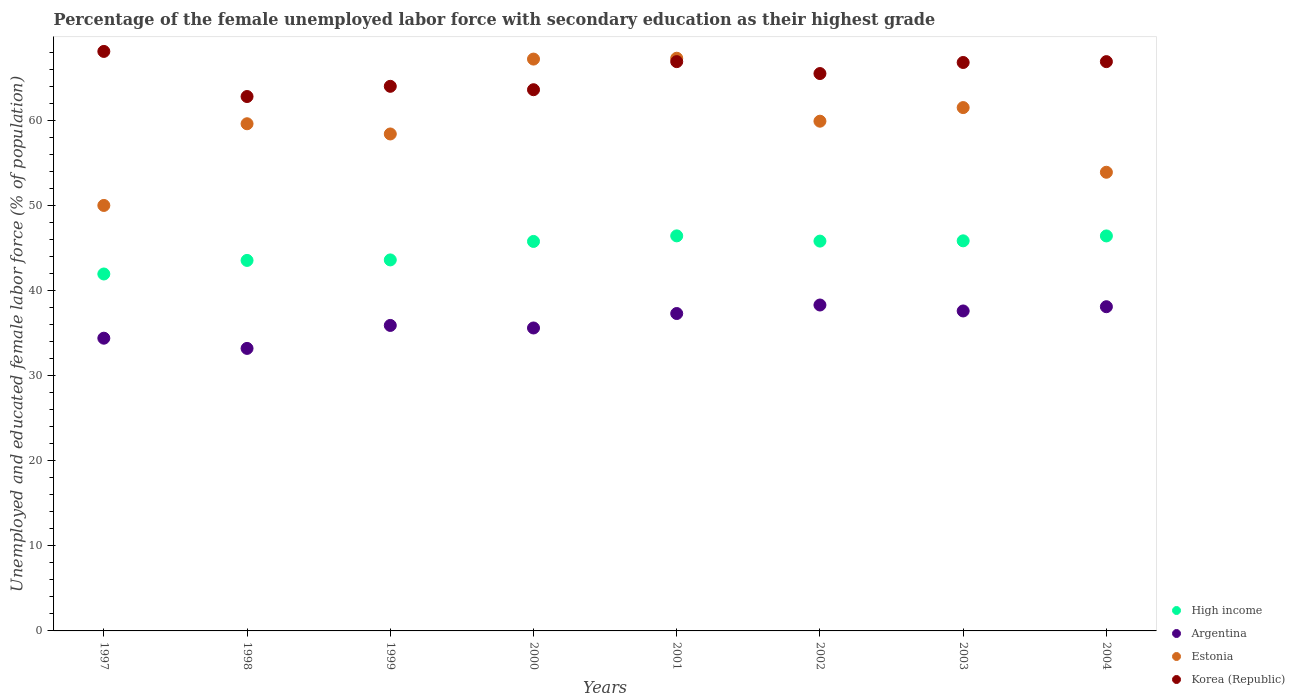How many different coloured dotlines are there?
Ensure brevity in your answer.  4. What is the percentage of the unemployed female labor force with secondary education in Korea (Republic) in 2004?
Make the answer very short. 66.9. Across all years, what is the maximum percentage of the unemployed female labor force with secondary education in Estonia?
Your response must be concise. 67.3. Across all years, what is the minimum percentage of the unemployed female labor force with secondary education in Korea (Republic)?
Your response must be concise. 62.8. In which year was the percentage of the unemployed female labor force with secondary education in High income minimum?
Provide a short and direct response. 1997. What is the total percentage of the unemployed female labor force with secondary education in High income in the graph?
Make the answer very short. 359.35. What is the difference between the percentage of the unemployed female labor force with secondary education in Korea (Republic) in 1997 and that in 1998?
Ensure brevity in your answer.  5.3. What is the difference between the percentage of the unemployed female labor force with secondary education in Argentina in 1997 and the percentage of the unemployed female labor force with secondary education in High income in 1999?
Give a very brief answer. -9.2. What is the average percentage of the unemployed female labor force with secondary education in Estonia per year?
Your response must be concise. 59.73. In the year 1999, what is the difference between the percentage of the unemployed female labor force with secondary education in Estonia and percentage of the unemployed female labor force with secondary education in Korea (Republic)?
Provide a succinct answer. -5.6. In how many years, is the percentage of the unemployed female labor force with secondary education in Argentina greater than 62 %?
Give a very brief answer. 0. What is the ratio of the percentage of the unemployed female labor force with secondary education in Argentina in 1999 to that in 2003?
Offer a terse response. 0.95. Is the percentage of the unemployed female labor force with secondary education in Argentina in 1997 less than that in 2002?
Your response must be concise. Yes. What is the difference between the highest and the second highest percentage of the unemployed female labor force with secondary education in Argentina?
Keep it short and to the point. 0.2. What is the difference between the highest and the lowest percentage of the unemployed female labor force with secondary education in High income?
Your answer should be very brief. 4.48. Is the sum of the percentage of the unemployed female labor force with secondary education in Argentina in 2000 and 2003 greater than the maximum percentage of the unemployed female labor force with secondary education in Korea (Republic) across all years?
Offer a terse response. Yes. Does the percentage of the unemployed female labor force with secondary education in Estonia monotonically increase over the years?
Provide a short and direct response. No. What is the difference between two consecutive major ticks on the Y-axis?
Provide a succinct answer. 10. Are the values on the major ticks of Y-axis written in scientific E-notation?
Your response must be concise. No. How many legend labels are there?
Make the answer very short. 4. How are the legend labels stacked?
Your response must be concise. Vertical. What is the title of the graph?
Provide a short and direct response. Percentage of the female unemployed labor force with secondary education as their highest grade. What is the label or title of the X-axis?
Provide a succinct answer. Years. What is the label or title of the Y-axis?
Ensure brevity in your answer.  Unemployed and educated female labor force (% of population). What is the Unemployed and educated female labor force (% of population) in High income in 1997?
Your response must be concise. 41.95. What is the Unemployed and educated female labor force (% of population) in Argentina in 1997?
Your answer should be compact. 34.4. What is the Unemployed and educated female labor force (% of population) of Korea (Republic) in 1997?
Provide a succinct answer. 68.1. What is the Unemployed and educated female labor force (% of population) in High income in 1998?
Your response must be concise. 43.54. What is the Unemployed and educated female labor force (% of population) of Argentina in 1998?
Provide a succinct answer. 33.2. What is the Unemployed and educated female labor force (% of population) in Estonia in 1998?
Provide a succinct answer. 59.6. What is the Unemployed and educated female labor force (% of population) in Korea (Republic) in 1998?
Ensure brevity in your answer.  62.8. What is the Unemployed and educated female labor force (% of population) in High income in 1999?
Keep it short and to the point. 43.6. What is the Unemployed and educated female labor force (% of population) of Argentina in 1999?
Make the answer very short. 35.9. What is the Unemployed and educated female labor force (% of population) of Estonia in 1999?
Provide a short and direct response. 58.4. What is the Unemployed and educated female labor force (% of population) in Korea (Republic) in 1999?
Offer a terse response. 64. What is the Unemployed and educated female labor force (% of population) in High income in 2000?
Ensure brevity in your answer.  45.77. What is the Unemployed and educated female labor force (% of population) in Argentina in 2000?
Offer a terse response. 35.6. What is the Unemployed and educated female labor force (% of population) of Estonia in 2000?
Give a very brief answer. 67.2. What is the Unemployed and educated female labor force (% of population) in Korea (Republic) in 2000?
Keep it short and to the point. 63.6. What is the Unemployed and educated female labor force (% of population) in High income in 2001?
Ensure brevity in your answer.  46.42. What is the Unemployed and educated female labor force (% of population) in Argentina in 2001?
Give a very brief answer. 37.3. What is the Unemployed and educated female labor force (% of population) of Estonia in 2001?
Give a very brief answer. 67.3. What is the Unemployed and educated female labor force (% of population) in Korea (Republic) in 2001?
Keep it short and to the point. 66.9. What is the Unemployed and educated female labor force (% of population) in High income in 2002?
Your answer should be very brief. 45.81. What is the Unemployed and educated female labor force (% of population) of Argentina in 2002?
Your response must be concise. 38.3. What is the Unemployed and educated female labor force (% of population) in Estonia in 2002?
Ensure brevity in your answer.  59.9. What is the Unemployed and educated female labor force (% of population) of Korea (Republic) in 2002?
Keep it short and to the point. 65.5. What is the Unemployed and educated female labor force (% of population) of High income in 2003?
Your answer should be very brief. 45.84. What is the Unemployed and educated female labor force (% of population) of Argentina in 2003?
Your answer should be compact. 37.6. What is the Unemployed and educated female labor force (% of population) of Estonia in 2003?
Keep it short and to the point. 61.5. What is the Unemployed and educated female labor force (% of population) in Korea (Republic) in 2003?
Ensure brevity in your answer.  66.8. What is the Unemployed and educated female labor force (% of population) in High income in 2004?
Provide a succinct answer. 46.42. What is the Unemployed and educated female labor force (% of population) in Argentina in 2004?
Offer a very short reply. 38.1. What is the Unemployed and educated female labor force (% of population) of Estonia in 2004?
Ensure brevity in your answer.  53.9. What is the Unemployed and educated female labor force (% of population) of Korea (Republic) in 2004?
Your answer should be very brief. 66.9. Across all years, what is the maximum Unemployed and educated female labor force (% of population) in High income?
Give a very brief answer. 46.42. Across all years, what is the maximum Unemployed and educated female labor force (% of population) of Argentina?
Provide a succinct answer. 38.3. Across all years, what is the maximum Unemployed and educated female labor force (% of population) in Estonia?
Your answer should be very brief. 67.3. Across all years, what is the maximum Unemployed and educated female labor force (% of population) of Korea (Republic)?
Make the answer very short. 68.1. Across all years, what is the minimum Unemployed and educated female labor force (% of population) in High income?
Ensure brevity in your answer.  41.95. Across all years, what is the minimum Unemployed and educated female labor force (% of population) of Argentina?
Keep it short and to the point. 33.2. Across all years, what is the minimum Unemployed and educated female labor force (% of population) in Korea (Republic)?
Your answer should be compact. 62.8. What is the total Unemployed and educated female labor force (% of population) in High income in the graph?
Ensure brevity in your answer.  359.35. What is the total Unemployed and educated female labor force (% of population) in Argentina in the graph?
Give a very brief answer. 290.4. What is the total Unemployed and educated female labor force (% of population) of Estonia in the graph?
Your response must be concise. 477.8. What is the total Unemployed and educated female labor force (% of population) of Korea (Republic) in the graph?
Give a very brief answer. 524.6. What is the difference between the Unemployed and educated female labor force (% of population) of High income in 1997 and that in 1998?
Offer a very short reply. -1.59. What is the difference between the Unemployed and educated female labor force (% of population) of Argentina in 1997 and that in 1998?
Ensure brevity in your answer.  1.2. What is the difference between the Unemployed and educated female labor force (% of population) in Estonia in 1997 and that in 1998?
Your answer should be compact. -9.6. What is the difference between the Unemployed and educated female labor force (% of population) of Korea (Republic) in 1997 and that in 1998?
Your response must be concise. 5.3. What is the difference between the Unemployed and educated female labor force (% of population) in High income in 1997 and that in 1999?
Provide a succinct answer. -1.65. What is the difference between the Unemployed and educated female labor force (% of population) of Estonia in 1997 and that in 1999?
Give a very brief answer. -8.4. What is the difference between the Unemployed and educated female labor force (% of population) in High income in 1997 and that in 2000?
Offer a very short reply. -3.83. What is the difference between the Unemployed and educated female labor force (% of population) of Estonia in 1997 and that in 2000?
Give a very brief answer. -17.2. What is the difference between the Unemployed and educated female labor force (% of population) in Korea (Republic) in 1997 and that in 2000?
Give a very brief answer. 4.5. What is the difference between the Unemployed and educated female labor force (% of population) in High income in 1997 and that in 2001?
Offer a very short reply. -4.48. What is the difference between the Unemployed and educated female labor force (% of population) of Estonia in 1997 and that in 2001?
Make the answer very short. -17.3. What is the difference between the Unemployed and educated female labor force (% of population) of High income in 1997 and that in 2002?
Offer a terse response. -3.86. What is the difference between the Unemployed and educated female labor force (% of population) in Argentina in 1997 and that in 2002?
Your answer should be very brief. -3.9. What is the difference between the Unemployed and educated female labor force (% of population) in Estonia in 1997 and that in 2002?
Your answer should be very brief. -9.9. What is the difference between the Unemployed and educated female labor force (% of population) in Korea (Republic) in 1997 and that in 2002?
Provide a succinct answer. 2.6. What is the difference between the Unemployed and educated female labor force (% of population) in High income in 1997 and that in 2003?
Provide a succinct answer. -3.9. What is the difference between the Unemployed and educated female labor force (% of population) of Argentina in 1997 and that in 2003?
Ensure brevity in your answer.  -3.2. What is the difference between the Unemployed and educated female labor force (% of population) in Estonia in 1997 and that in 2003?
Your answer should be very brief. -11.5. What is the difference between the Unemployed and educated female labor force (% of population) of Korea (Republic) in 1997 and that in 2003?
Offer a very short reply. 1.3. What is the difference between the Unemployed and educated female labor force (% of population) of High income in 1997 and that in 2004?
Give a very brief answer. -4.47. What is the difference between the Unemployed and educated female labor force (% of population) of Korea (Republic) in 1997 and that in 2004?
Make the answer very short. 1.2. What is the difference between the Unemployed and educated female labor force (% of population) in High income in 1998 and that in 1999?
Provide a succinct answer. -0.06. What is the difference between the Unemployed and educated female labor force (% of population) of High income in 1998 and that in 2000?
Your answer should be very brief. -2.23. What is the difference between the Unemployed and educated female labor force (% of population) in Argentina in 1998 and that in 2000?
Provide a succinct answer. -2.4. What is the difference between the Unemployed and educated female labor force (% of population) of Estonia in 1998 and that in 2000?
Ensure brevity in your answer.  -7.6. What is the difference between the Unemployed and educated female labor force (% of population) in Korea (Republic) in 1998 and that in 2000?
Your answer should be very brief. -0.8. What is the difference between the Unemployed and educated female labor force (% of population) in High income in 1998 and that in 2001?
Give a very brief answer. -2.88. What is the difference between the Unemployed and educated female labor force (% of population) in Estonia in 1998 and that in 2001?
Make the answer very short. -7.7. What is the difference between the Unemployed and educated female labor force (% of population) of Korea (Republic) in 1998 and that in 2001?
Offer a very short reply. -4.1. What is the difference between the Unemployed and educated female labor force (% of population) of High income in 1998 and that in 2002?
Your answer should be very brief. -2.27. What is the difference between the Unemployed and educated female labor force (% of population) of Estonia in 1998 and that in 2002?
Your answer should be compact. -0.3. What is the difference between the Unemployed and educated female labor force (% of population) of Korea (Republic) in 1998 and that in 2002?
Provide a short and direct response. -2.7. What is the difference between the Unemployed and educated female labor force (% of population) of High income in 1998 and that in 2003?
Make the answer very short. -2.3. What is the difference between the Unemployed and educated female labor force (% of population) in Estonia in 1998 and that in 2003?
Give a very brief answer. -1.9. What is the difference between the Unemployed and educated female labor force (% of population) of High income in 1998 and that in 2004?
Your answer should be compact. -2.88. What is the difference between the Unemployed and educated female labor force (% of population) of Argentina in 1998 and that in 2004?
Ensure brevity in your answer.  -4.9. What is the difference between the Unemployed and educated female labor force (% of population) of Estonia in 1998 and that in 2004?
Ensure brevity in your answer.  5.7. What is the difference between the Unemployed and educated female labor force (% of population) of High income in 1999 and that in 2000?
Make the answer very short. -2.17. What is the difference between the Unemployed and educated female labor force (% of population) in Argentina in 1999 and that in 2000?
Offer a terse response. 0.3. What is the difference between the Unemployed and educated female labor force (% of population) of Korea (Republic) in 1999 and that in 2000?
Provide a short and direct response. 0.4. What is the difference between the Unemployed and educated female labor force (% of population) of High income in 1999 and that in 2001?
Your answer should be very brief. -2.82. What is the difference between the Unemployed and educated female labor force (% of population) in High income in 1999 and that in 2002?
Your answer should be very brief. -2.21. What is the difference between the Unemployed and educated female labor force (% of population) of Korea (Republic) in 1999 and that in 2002?
Your response must be concise. -1.5. What is the difference between the Unemployed and educated female labor force (% of population) in High income in 1999 and that in 2003?
Give a very brief answer. -2.24. What is the difference between the Unemployed and educated female labor force (% of population) in Argentina in 1999 and that in 2003?
Your response must be concise. -1.7. What is the difference between the Unemployed and educated female labor force (% of population) of Estonia in 1999 and that in 2003?
Offer a terse response. -3.1. What is the difference between the Unemployed and educated female labor force (% of population) of High income in 1999 and that in 2004?
Make the answer very short. -2.82. What is the difference between the Unemployed and educated female labor force (% of population) in Argentina in 1999 and that in 2004?
Offer a very short reply. -2.2. What is the difference between the Unemployed and educated female labor force (% of population) of Korea (Republic) in 1999 and that in 2004?
Keep it short and to the point. -2.9. What is the difference between the Unemployed and educated female labor force (% of population) in High income in 2000 and that in 2001?
Make the answer very short. -0.65. What is the difference between the Unemployed and educated female labor force (% of population) in Argentina in 2000 and that in 2001?
Give a very brief answer. -1.7. What is the difference between the Unemployed and educated female labor force (% of population) of Korea (Republic) in 2000 and that in 2001?
Make the answer very short. -3.3. What is the difference between the Unemployed and educated female labor force (% of population) in High income in 2000 and that in 2002?
Offer a very short reply. -0.04. What is the difference between the Unemployed and educated female labor force (% of population) in High income in 2000 and that in 2003?
Your answer should be compact. -0.07. What is the difference between the Unemployed and educated female labor force (% of population) in Estonia in 2000 and that in 2003?
Your answer should be very brief. 5.7. What is the difference between the Unemployed and educated female labor force (% of population) in Korea (Republic) in 2000 and that in 2003?
Provide a short and direct response. -3.2. What is the difference between the Unemployed and educated female labor force (% of population) of High income in 2000 and that in 2004?
Keep it short and to the point. -0.65. What is the difference between the Unemployed and educated female labor force (% of population) in Korea (Republic) in 2000 and that in 2004?
Your answer should be compact. -3.3. What is the difference between the Unemployed and educated female labor force (% of population) in High income in 2001 and that in 2002?
Your answer should be very brief. 0.62. What is the difference between the Unemployed and educated female labor force (% of population) in Argentina in 2001 and that in 2002?
Your response must be concise. -1. What is the difference between the Unemployed and educated female labor force (% of population) in Estonia in 2001 and that in 2002?
Your response must be concise. 7.4. What is the difference between the Unemployed and educated female labor force (% of population) in High income in 2001 and that in 2003?
Ensure brevity in your answer.  0.58. What is the difference between the Unemployed and educated female labor force (% of population) in Argentina in 2001 and that in 2003?
Make the answer very short. -0.3. What is the difference between the Unemployed and educated female labor force (% of population) of Estonia in 2001 and that in 2003?
Offer a very short reply. 5.8. What is the difference between the Unemployed and educated female labor force (% of population) in High income in 2001 and that in 2004?
Give a very brief answer. 0.01. What is the difference between the Unemployed and educated female labor force (% of population) in High income in 2002 and that in 2003?
Make the answer very short. -0.03. What is the difference between the Unemployed and educated female labor force (% of population) of Argentina in 2002 and that in 2003?
Give a very brief answer. 0.7. What is the difference between the Unemployed and educated female labor force (% of population) of Korea (Republic) in 2002 and that in 2003?
Ensure brevity in your answer.  -1.3. What is the difference between the Unemployed and educated female labor force (% of population) in High income in 2002 and that in 2004?
Give a very brief answer. -0.61. What is the difference between the Unemployed and educated female labor force (% of population) in Argentina in 2002 and that in 2004?
Provide a succinct answer. 0.2. What is the difference between the Unemployed and educated female labor force (% of population) in Estonia in 2002 and that in 2004?
Provide a succinct answer. 6. What is the difference between the Unemployed and educated female labor force (% of population) of Korea (Republic) in 2002 and that in 2004?
Provide a succinct answer. -1.4. What is the difference between the Unemployed and educated female labor force (% of population) in High income in 2003 and that in 2004?
Give a very brief answer. -0.58. What is the difference between the Unemployed and educated female labor force (% of population) in Estonia in 2003 and that in 2004?
Your response must be concise. 7.6. What is the difference between the Unemployed and educated female labor force (% of population) in Korea (Republic) in 2003 and that in 2004?
Your answer should be compact. -0.1. What is the difference between the Unemployed and educated female labor force (% of population) of High income in 1997 and the Unemployed and educated female labor force (% of population) of Argentina in 1998?
Offer a very short reply. 8.75. What is the difference between the Unemployed and educated female labor force (% of population) in High income in 1997 and the Unemployed and educated female labor force (% of population) in Estonia in 1998?
Your answer should be very brief. -17.65. What is the difference between the Unemployed and educated female labor force (% of population) of High income in 1997 and the Unemployed and educated female labor force (% of population) of Korea (Republic) in 1998?
Give a very brief answer. -20.85. What is the difference between the Unemployed and educated female labor force (% of population) in Argentina in 1997 and the Unemployed and educated female labor force (% of population) in Estonia in 1998?
Ensure brevity in your answer.  -25.2. What is the difference between the Unemployed and educated female labor force (% of population) in Argentina in 1997 and the Unemployed and educated female labor force (% of population) in Korea (Republic) in 1998?
Give a very brief answer. -28.4. What is the difference between the Unemployed and educated female labor force (% of population) of Estonia in 1997 and the Unemployed and educated female labor force (% of population) of Korea (Republic) in 1998?
Offer a terse response. -12.8. What is the difference between the Unemployed and educated female labor force (% of population) of High income in 1997 and the Unemployed and educated female labor force (% of population) of Argentina in 1999?
Make the answer very short. 6.05. What is the difference between the Unemployed and educated female labor force (% of population) of High income in 1997 and the Unemployed and educated female labor force (% of population) of Estonia in 1999?
Ensure brevity in your answer.  -16.45. What is the difference between the Unemployed and educated female labor force (% of population) in High income in 1997 and the Unemployed and educated female labor force (% of population) in Korea (Republic) in 1999?
Keep it short and to the point. -22.05. What is the difference between the Unemployed and educated female labor force (% of population) of Argentina in 1997 and the Unemployed and educated female labor force (% of population) of Estonia in 1999?
Your response must be concise. -24. What is the difference between the Unemployed and educated female labor force (% of population) in Argentina in 1997 and the Unemployed and educated female labor force (% of population) in Korea (Republic) in 1999?
Make the answer very short. -29.6. What is the difference between the Unemployed and educated female labor force (% of population) in High income in 1997 and the Unemployed and educated female labor force (% of population) in Argentina in 2000?
Ensure brevity in your answer.  6.35. What is the difference between the Unemployed and educated female labor force (% of population) in High income in 1997 and the Unemployed and educated female labor force (% of population) in Estonia in 2000?
Make the answer very short. -25.25. What is the difference between the Unemployed and educated female labor force (% of population) in High income in 1997 and the Unemployed and educated female labor force (% of population) in Korea (Republic) in 2000?
Your answer should be compact. -21.65. What is the difference between the Unemployed and educated female labor force (% of population) in Argentina in 1997 and the Unemployed and educated female labor force (% of population) in Estonia in 2000?
Make the answer very short. -32.8. What is the difference between the Unemployed and educated female labor force (% of population) in Argentina in 1997 and the Unemployed and educated female labor force (% of population) in Korea (Republic) in 2000?
Make the answer very short. -29.2. What is the difference between the Unemployed and educated female labor force (% of population) of High income in 1997 and the Unemployed and educated female labor force (% of population) of Argentina in 2001?
Provide a succinct answer. 4.65. What is the difference between the Unemployed and educated female labor force (% of population) in High income in 1997 and the Unemployed and educated female labor force (% of population) in Estonia in 2001?
Provide a short and direct response. -25.35. What is the difference between the Unemployed and educated female labor force (% of population) in High income in 1997 and the Unemployed and educated female labor force (% of population) in Korea (Republic) in 2001?
Provide a succinct answer. -24.95. What is the difference between the Unemployed and educated female labor force (% of population) in Argentina in 1997 and the Unemployed and educated female labor force (% of population) in Estonia in 2001?
Offer a very short reply. -32.9. What is the difference between the Unemployed and educated female labor force (% of population) in Argentina in 1997 and the Unemployed and educated female labor force (% of population) in Korea (Republic) in 2001?
Make the answer very short. -32.5. What is the difference between the Unemployed and educated female labor force (% of population) in Estonia in 1997 and the Unemployed and educated female labor force (% of population) in Korea (Republic) in 2001?
Make the answer very short. -16.9. What is the difference between the Unemployed and educated female labor force (% of population) in High income in 1997 and the Unemployed and educated female labor force (% of population) in Argentina in 2002?
Keep it short and to the point. 3.65. What is the difference between the Unemployed and educated female labor force (% of population) in High income in 1997 and the Unemployed and educated female labor force (% of population) in Estonia in 2002?
Provide a short and direct response. -17.95. What is the difference between the Unemployed and educated female labor force (% of population) in High income in 1997 and the Unemployed and educated female labor force (% of population) in Korea (Republic) in 2002?
Your answer should be compact. -23.55. What is the difference between the Unemployed and educated female labor force (% of population) in Argentina in 1997 and the Unemployed and educated female labor force (% of population) in Estonia in 2002?
Provide a succinct answer. -25.5. What is the difference between the Unemployed and educated female labor force (% of population) of Argentina in 1997 and the Unemployed and educated female labor force (% of population) of Korea (Republic) in 2002?
Offer a very short reply. -31.1. What is the difference between the Unemployed and educated female labor force (% of population) of Estonia in 1997 and the Unemployed and educated female labor force (% of population) of Korea (Republic) in 2002?
Your answer should be compact. -15.5. What is the difference between the Unemployed and educated female labor force (% of population) in High income in 1997 and the Unemployed and educated female labor force (% of population) in Argentina in 2003?
Provide a succinct answer. 4.35. What is the difference between the Unemployed and educated female labor force (% of population) of High income in 1997 and the Unemployed and educated female labor force (% of population) of Estonia in 2003?
Ensure brevity in your answer.  -19.55. What is the difference between the Unemployed and educated female labor force (% of population) of High income in 1997 and the Unemployed and educated female labor force (% of population) of Korea (Republic) in 2003?
Provide a short and direct response. -24.85. What is the difference between the Unemployed and educated female labor force (% of population) of Argentina in 1997 and the Unemployed and educated female labor force (% of population) of Estonia in 2003?
Make the answer very short. -27.1. What is the difference between the Unemployed and educated female labor force (% of population) of Argentina in 1997 and the Unemployed and educated female labor force (% of population) of Korea (Republic) in 2003?
Ensure brevity in your answer.  -32.4. What is the difference between the Unemployed and educated female labor force (% of population) in Estonia in 1997 and the Unemployed and educated female labor force (% of population) in Korea (Republic) in 2003?
Offer a terse response. -16.8. What is the difference between the Unemployed and educated female labor force (% of population) of High income in 1997 and the Unemployed and educated female labor force (% of population) of Argentina in 2004?
Offer a very short reply. 3.85. What is the difference between the Unemployed and educated female labor force (% of population) in High income in 1997 and the Unemployed and educated female labor force (% of population) in Estonia in 2004?
Provide a succinct answer. -11.95. What is the difference between the Unemployed and educated female labor force (% of population) in High income in 1997 and the Unemployed and educated female labor force (% of population) in Korea (Republic) in 2004?
Your answer should be compact. -24.95. What is the difference between the Unemployed and educated female labor force (% of population) of Argentina in 1997 and the Unemployed and educated female labor force (% of population) of Estonia in 2004?
Keep it short and to the point. -19.5. What is the difference between the Unemployed and educated female labor force (% of population) in Argentina in 1997 and the Unemployed and educated female labor force (% of population) in Korea (Republic) in 2004?
Make the answer very short. -32.5. What is the difference between the Unemployed and educated female labor force (% of population) of Estonia in 1997 and the Unemployed and educated female labor force (% of population) of Korea (Republic) in 2004?
Give a very brief answer. -16.9. What is the difference between the Unemployed and educated female labor force (% of population) of High income in 1998 and the Unemployed and educated female labor force (% of population) of Argentina in 1999?
Offer a terse response. 7.64. What is the difference between the Unemployed and educated female labor force (% of population) in High income in 1998 and the Unemployed and educated female labor force (% of population) in Estonia in 1999?
Ensure brevity in your answer.  -14.86. What is the difference between the Unemployed and educated female labor force (% of population) of High income in 1998 and the Unemployed and educated female labor force (% of population) of Korea (Republic) in 1999?
Your answer should be very brief. -20.46. What is the difference between the Unemployed and educated female labor force (% of population) of Argentina in 1998 and the Unemployed and educated female labor force (% of population) of Estonia in 1999?
Make the answer very short. -25.2. What is the difference between the Unemployed and educated female labor force (% of population) in Argentina in 1998 and the Unemployed and educated female labor force (% of population) in Korea (Republic) in 1999?
Your answer should be compact. -30.8. What is the difference between the Unemployed and educated female labor force (% of population) of High income in 1998 and the Unemployed and educated female labor force (% of population) of Argentina in 2000?
Your answer should be compact. 7.94. What is the difference between the Unemployed and educated female labor force (% of population) of High income in 1998 and the Unemployed and educated female labor force (% of population) of Estonia in 2000?
Ensure brevity in your answer.  -23.66. What is the difference between the Unemployed and educated female labor force (% of population) of High income in 1998 and the Unemployed and educated female labor force (% of population) of Korea (Republic) in 2000?
Offer a very short reply. -20.06. What is the difference between the Unemployed and educated female labor force (% of population) in Argentina in 1998 and the Unemployed and educated female labor force (% of population) in Estonia in 2000?
Keep it short and to the point. -34. What is the difference between the Unemployed and educated female labor force (% of population) of Argentina in 1998 and the Unemployed and educated female labor force (% of population) of Korea (Republic) in 2000?
Ensure brevity in your answer.  -30.4. What is the difference between the Unemployed and educated female labor force (% of population) of Estonia in 1998 and the Unemployed and educated female labor force (% of population) of Korea (Republic) in 2000?
Your answer should be compact. -4. What is the difference between the Unemployed and educated female labor force (% of population) in High income in 1998 and the Unemployed and educated female labor force (% of population) in Argentina in 2001?
Your answer should be very brief. 6.24. What is the difference between the Unemployed and educated female labor force (% of population) in High income in 1998 and the Unemployed and educated female labor force (% of population) in Estonia in 2001?
Offer a very short reply. -23.76. What is the difference between the Unemployed and educated female labor force (% of population) in High income in 1998 and the Unemployed and educated female labor force (% of population) in Korea (Republic) in 2001?
Provide a succinct answer. -23.36. What is the difference between the Unemployed and educated female labor force (% of population) of Argentina in 1998 and the Unemployed and educated female labor force (% of population) of Estonia in 2001?
Offer a terse response. -34.1. What is the difference between the Unemployed and educated female labor force (% of population) of Argentina in 1998 and the Unemployed and educated female labor force (% of population) of Korea (Republic) in 2001?
Give a very brief answer. -33.7. What is the difference between the Unemployed and educated female labor force (% of population) of High income in 1998 and the Unemployed and educated female labor force (% of population) of Argentina in 2002?
Provide a succinct answer. 5.24. What is the difference between the Unemployed and educated female labor force (% of population) in High income in 1998 and the Unemployed and educated female labor force (% of population) in Estonia in 2002?
Your response must be concise. -16.36. What is the difference between the Unemployed and educated female labor force (% of population) of High income in 1998 and the Unemployed and educated female labor force (% of population) of Korea (Republic) in 2002?
Provide a short and direct response. -21.96. What is the difference between the Unemployed and educated female labor force (% of population) of Argentina in 1998 and the Unemployed and educated female labor force (% of population) of Estonia in 2002?
Give a very brief answer. -26.7. What is the difference between the Unemployed and educated female labor force (% of population) in Argentina in 1998 and the Unemployed and educated female labor force (% of population) in Korea (Republic) in 2002?
Ensure brevity in your answer.  -32.3. What is the difference between the Unemployed and educated female labor force (% of population) of Estonia in 1998 and the Unemployed and educated female labor force (% of population) of Korea (Republic) in 2002?
Offer a very short reply. -5.9. What is the difference between the Unemployed and educated female labor force (% of population) in High income in 1998 and the Unemployed and educated female labor force (% of population) in Argentina in 2003?
Your answer should be very brief. 5.94. What is the difference between the Unemployed and educated female labor force (% of population) of High income in 1998 and the Unemployed and educated female labor force (% of population) of Estonia in 2003?
Offer a very short reply. -17.96. What is the difference between the Unemployed and educated female labor force (% of population) of High income in 1998 and the Unemployed and educated female labor force (% of population) of Korea (Republic) in 2003?
Offer a very short reply. -23.26. What is the difference between the Unemployed and educated female labor force (% of population) in Argentina in 1998 and the Unemployed and educated female labor force (% of population) in Estonia in 2003?
Give a very brief answer. -28.3. What is the difference between the Unemployed and educated female labor force (% of population) in Argentina in 1998 and the Unemployed and educated female labor force (% of population) in Korea (Republic) in 2003?
Provide a short and direct response. -33.6. What is the difference between the Unemployed and educated female labor force (% of population) of High income in 1998 and the Unemployed and educated female labor force (% of population) of Argentina in 2004?
Ensure brevity in your answer.  5.44. What is the difference between the Unemployed and educated female labor force (% of population) in High income in 1998 and the Unemployed and educated female labor force (% of population) in Estonia in 2004?
Offer a terse response. -10.36. What is the difference between the Unemployed and educated female labor force (% of population) of High income in 1998 and the Unemployed and educated female labor force (% of population) of Korea (Republic) in 2004?
Your answer should be very brief. -23.36. What is the difference between the Unemployed and educated female labor force (% of population) of Argentina in 1998 and the Unemployed and educated female labor force (% of population) of Estonia in 2004?
Offer a terse response. -20.7. What is the difference between the Unemployed and educated female labor force (% of population) in Argentina in 1998 and the Unemployed and educated female labor force (% of population) in Korea (Republic) in 2004?
Ensure brevity in your answer.  -33.7. What is the difference between the Unemployed and educated female labor force (% of population) of Estonia in 1998 and the Unemployed and educated female labor force (% of population) of Korea (Republic) in 2004?
Keep it short and to the point. -7.3. What is the difference between the Unemployed and educated female labor force (% of population) in High income in 1999 and the Unemployed and educated female labor force (% of population) in Argentina in 2000?
Make the answer very short. 8. What is the difference between the Unemployed and educated female labor force (% of population) in High income in 1999 and the Unemployed and educated female labor force (% of population) in Estonia in 2000?
Provide a succinct answer. -23.6. What is the difference between the Unemployed and educated female labor force (% of population) in High income in 1999 and the Unemployed and educated female labor force (% of population) in Korea (Republic) in 2000?
Keep it short and to the point. -20. What is the difference between the Unemployed and educated female labor force (% of population) in Argentina in 1999 and the Unemployed and educated female labor force (% of population) in Estonia in 2000?
Your response must be concise. -31.3. What is the difference between the Unemployed and educated female labor force (% of population) in Argentina in 1999 and the Unemployed and educated female labor force (% of population) in Korea (Republic) in 2000?
Ensure brevity in your answer.  -27.7. What is the difference between the Unemployed and educated female labor force (% of population) of Estonia in 1999 and the Unemployed and educated female labor force (% of population) of Korea (Republic) in 2000?
Your answer should be very brief. -5.2. What is the difference between the Unemployed and educated female labor force (% of population) in High income in 1999 and the Unemployed and educated female labor force (% of population) in Argentina in 2001?
Make the answer very short. 6.3. What is the difference between the Unemployed and educated female labor force (% of population) of High income in 1999 and the Unemployed and educated female labor force (% of population) of Estonia in 2001?
Provide a short and direct response. -23.7. What is the difference between the Unemployed and educated female labor force (% of population) of High income in 1999 and the Unemployed and educated female labor force (% of population) of Korea (Republic) in 2001?
Make the answer very short. -23.3. What is the difference between the Unemployed and educated female labor force (% of population) in Argentina in 1999 and the Unemployed and educated female labor force (% of population) in Estonia in 2001?
Your response must be concise. -31.4. What is the difference between the Unemployed and educated female labor force (% of population) in Argentina in 1999 and the Unemployed and educated female labor force (% of population) in Korea (Republic) in 2001?
Your response must be concise. -31. What is the difference between the Unemployed and educated female labor force (% of population) in High income in 1999 and the Unemployed and educated female labor force (% of population) in Argentina in 2002?
Provide a short and direct response. 5.3. What is the difference between the Unemployed and educated female labor force (% of population) of High income in 1999 and the Unemployed and educated female labor force (% of population) of Estonia in 2002?
Your answer should be compact. -16.3. What is the difference between the Unemployed and educated female labor force (% of population) of High income in 1999 and the Unemployed and educated female labor force (% of population) of Korea (Republic) in 2002?
Your answer should be compact. -21.9. What is the difference between the Unemployed and educated female labor force (% of population) in Argentina in 1999 and the Unemployed and educated female labor force (% of population) in Estonia in 2002?
Your answer should be very brief. -24. What is the difference between the Unemployed and educated female labor force (% of population) of Argentina in 1999 and the Unemployed and educated female labor force (% of population) of Korea (Republic) in 2002?
Give a very brief answer. -29.6. What is the difference between the Unemployed and educated female labor force (% of population) in Estonia in 1999 and the Unemployed and educated female labor force (% of population) in Korea (Republic) in 2002?
Provide a short and direct response. -7.1. What is the difference between the Unemployed and educated female labor force (% of population) of High income in 1999 and the Unemployed and educated female labor force (% of population) of Argentina in 2003?
Make the answer very short. 6. What is the difference between the Unemployed and educated female labor force (% of population) in High income in 1999 and the Unemployed and educated female labor force (% of population) in Estonia in 2003?
Your response must be concise. -17.9. What is the difference between the Unemployed and educated female labor force (% of population) in High income in 1999 and the Unemployed and educated female labor force (% of population) in Korea (Republic) in 2003?
Ensure brevity in your answer.  -23.2. What is the difference between the Unemployed and educated female labor force (% of population) of Argentina in 1999 and the Unemployed and educated female labor force (% of population) of Estonia in 2003?
Give a very brief answer. -25.6. What is the difference between the Unemployed and educated female labor force (% of population) of Argentina in 1999 and the Unemployed and educated female labor force (% of population) of Korea (Republic) in 2003?
Your answer should be compact. -30.9. What is the difference between the Unemployed and educated female labor force (% of population) in High income in 1999 and the Unemployed and educated female labor force (% of population) in Argentina in 2004?
Your answer should be compact. 5.5. What is the difference between the Unemployed and educated female labor force (% of population) of High income in 1999 and the Unemployed and educated female labor force (% of population) of Estonia in 2004?
Your response must be concise. -10.3. What is the difference between the Unemployed and educated female labor force (% of population) of High income in 1999 and the Unemployed and educated female labor force (% of population) of Korea (Republic) in 2004?
Offer a very short reply. -23.3. What is the difference between the Unemployed and educated female labor force (% of population) in Argentina in 1999 and the Unemployed and educated female labor force (% of population) in Estonia in 2004?
Ensure brevity in your answer.  -18. What is the difference between the Unemployed and educated female labor force (% of population) in Argentina in 1999 and the Unemployed and educated female labor force (% of population) in Korea (Republic) in 2004?
Ensure brevity in your answer.  -31. What is the difference between the Unemployed and educated female labor force (% of population) in Estonia in 1999 and the Unemployed and educated female labor force (% of population) in Korea (Republic) in 2004?
Ensure brevity in your answer.  -8.5. What is the difference between the Unemployed and educated female labor force (% of population) in High income in 2000 and the Unemployed and educated female labor force (% of population) in Argentina in 2001?
Make the answer very short. 8.47. What is the difference between the Unemployed and educated female labor force (% of population) in High income in 2000 and the Unemployed and educated female labor force (% of population) in Estonia in 2001?
Your response must be concise. -21.53. What is the difference between the Unemployed and educated female labor force (% of population) in High income in 2000 and the Unemployed and educated female labor force (% of population) in Korea (Republic) in 2001?
Offer a very short reply. -21.13. What is the difference between the Unemployed and educated female labor force (% of population) in Argentina in 2000 and the Unemployed and educated female labor force (% of population) in Estonia in 2001?
Your answer should be compact. -31.7. What is the difference between the Unemployed and educated female labor force (% of population) in Argentina in 2000 and the Unemployed and educated female labor force (% of population) in Korea (Republic) in 2001?
Your answer should be very brief. -31.3. What is the difference between the Unemployed and educated female labor force (% of population) in Estonia in 2000 and the Unemployed and educated female labor force (% of population) in Korea (Republic) in 2001?
Make the answer very short. 0.3. What is the difference between the Unemployed and educated female labor force (% of population) in High income in 2000 and the Unemployed and educated female labor force (% of population) in Argentina in 2002?
Offer a very short reply. 7.47. What is the difference between the Unemployed and educated female labor force (% of population) of High income in 2000 and the Unemployed and educated female labor force (% of population) of Estonia in 2002?
Your answer should be compact. -14.13. What is the difference between the Unemployed and educated female labor force (% of population) in High income in 2000 and the Unemployed and educated female labor force (% of population) in Korea (Republic) in 2002?
Offer a very short reply. -19.73. What is the difference between the Unemployed and educated female labor force (% of population) of Argentina in 2000 and the Unemployed and educated female labor force (% of population) of Estonia in 2002?
Your answer should be compact. -24.3. What is the difference between the Unemployed and educated female labor force (% of population) of Argentina in 2000 and the Unemployed and educated female labor force (% of population) of Korea (Republic) in 2002?
Your answer should be very brief. -29.9. What is the difference between the Unemployed and educated female labor force (% of population) of Estonia in 2000 and the Unemployed and educated female labor force (% of population) of Korea (Republic) in 2002?
Your answer should be compact. 1.7. What is the difference between the Unemployed and educated female labor force (% of population) in High income in 2000 and the Unemployed and educated female labor force (% of population) in Argentina in 2003?
Provide a short and direct response. 8.17. What is the difference between the Unemployed and educated female labor force (% of population) in High income in 2000 and the Unemployed and educated female labor force (% of population) in Estonia in 2003?
Give a very brief answer. -15.73. What is the difference between the Unemployed and educated female labor force (% of population) of High income in 2000 and the Unemployed and educated female labor force (% of population) of Korea (Republic) in 2003?
Ensure brevity in your answer.  -21.03. What is the difference between the Unemployed and educated female labor force (% of population) in Argentina in 2000 and the Unemployed and educated female labor force (% of population) in Estonia in 2003?
Give a very brief answer. -25.9. What is the difference between the Unemployed and educated female labor force (% of population) in Argentina in 2000 and the Unemployed and educated female labor force (% of population) in Korea (Republic) in 2003?
Make the answer very short. -31.2. What is the difference between the Unemployed and educated female labor force (% of population) of Estonia in 2000 and the Unemployed and educated female labor force (% of population) of Korea (Republic) in 2003?
Your answer should be very brief. 0.4. What is the difference between the Unemployed and educated female labor force (% of population) in High income in 2000 and the Unemployed and educated female labor force (% of population) in Argentina in 2004?
Provide a succinct answer. 7.67. What is the difference between the Unemployed and educated female labor force (% of population) in High income in 2000 and the Unemployed and educated female labor force (% of population) in Estonia in 2004?
Make the answer very short. -8.13. What is the difference between the Unemployed and educated female labor force (% of population) in High income in 2000 and the Unemployed and educated female labor force (% of population) in Korea (Republic) in 2004?
Your answer should be very brief. -21.13. What is the difference between the Unemployed and educated female labor force (% of population) in Argentina in 2000 and the Unemployed and educated female labor force (% of population) in Estonia in 2004?
Your answer should be compact. -18.3. What is the difference between the Unemployed and educated female labor force (% of population) of Argentina in 2000 and the Unemployed and educated female labor force (% of population) of Korea (Republic) in 2004?
Give a very brief answer. -31.3. What is the difference between the Unemployed and educated female labor force (% of population) in Estonia in 2000 and the Unemployed and educated female labor force (% of population) in Korea (Republic) in 2004?
Ensure brevity in your answer.  0.3. What is the difference between the Unemployed and educated female labor force (% of population) of High income in 2001 and the Unemployed and educated female labor force (% of population) of Argentina in 2002?
Ensure brevity in your answer.  8.12. What is the difference between the Unemployed and educated female labor force (% of population) of High income in 2001 and the Unemployed and educated female labor force (% of population) of Estonia in 2002?
Your answer should be very brief. -13.48. What is the difference between the Unemployed and educated female labor force (% of population) in High income in 2001 and the Unemployed and educated female labor force (% of population) in Korea (Republic) in 2002?
Offer a terse response. -19.08. What is the difference between the Unemployed and educated female labor force (% of population) in Argentina in 2001 and the Unemployed and educated female labor force (% of population) in Estonia in 2002?
Keep it short and to the point. -22.6. What is the difference between the Unemployed and educated female labor force (% of population) of Argentina in 2001 and the Unemployed and educated female labor force (% of population) of Korea (Republic) in 2002?
Make the answer very short. -28.2. What is the difference between the Unemployed and educated female labor force (% of population) of Estonia in 2001 and the Unemployed and educated female labor force (% of population) of Korea (Republic) in 2002?
Offer a terse response. 1.8. What is the difference between the Unemployed and educated female labor force (% of population) of High income in 2001 and the Unemployed and educated female labor force (% of population) of Argentina in 2003?
Give a very brief answer. 8.82. What is the difference between the Unemployed and educated female labor force (% of population) of High income in 2001 and the Unemployed and educated female labor force (% of population) of Estonia in 2003?
Make the answer very short. -15.08. What is the difference between the Unemployed and educated female labor force (% of population) in High income in 2001 and the Unemployed and educated female labor force (% of population) in Korea (Republic) in 2003?
Keep it short and to the point. -20.38. What is the difference between the Unemployed and educated female labor force (% of population) in Argentina in 2001 and the Unemployed and educated female labor force (% of population) in Estonia in 2003?
Keep it short and to the point. -24.2. What is the difference between the Unemployed and educated female labor force (% of population) of Argentina in 2001 and the Unemployed and educated female labor force (% of population) of Korea (Republic) in 2003?
Offer a terse response. -29.5. What is the difference between the Unemployed and educated female labor force (% of population) of High income in 2001 and the Unemployed and educated female labor force (% of population) of Argentina in 2004?
Your answer should be compact. 8.32. What is the difference between the Unemployed and educated female labor force (% of population) in High income in 2001 and the Unemployed and educated female labor force (% of population) in Estonia in 2004?
Offer a very short reply. -7.48. What is the difference between the Unemployed and educated female labor force (% of population) in High income in 2001 and the Unemployed and educated female labor force (% of population) in Korea (Republic) in 2004?
Make the answer very short. -20.48. What is the difference between the Unemployed and educated female labor force (% of population) in Argentina in 2001 and the Unemployed and educated female labor force (% of population) in Estonia in 2004?
Make the answer very short. -16.6. What is the difference between the Unemployed and educated female labor force (% of population) of Argentina in 2001 and the Unemployed and educated female labor force (% of population) of Korea (Republic) in 2004?
Your answer should be very brief. -29.6. What is the difference between the Unemployed and educated female labor force (% of population) in High income in 2002 and the Unemployed and educated female labor force (% of population) in Argentina in 2003?
Ensure brevity in your answer.  8.21. What is the difference between the Unemployed and educated female labor force (% of population) of High income in 2002 and the Unemployed and educated female labor force (% of population) of Estonia in 2003?
Offer a very short reply. -15.69. What is the difference between the Unemployed and educated female labor force (% of population) in High income in 2002 and the Unemployed and educated female labor force (% of population) in Korea (Republic) in 2003?
Make the answer very short. -20.99. What is the difference between the Unemployed and educated female labor force (% of population) of Argentina in 2002 and the Unemployed and educated female labor force (% of population) of Estonia in 2003?
Offer a terse response. -23.2. What is the difference between the Unemployed and educated female labor force (% of population) in Argentina in 2002 and the Unemployed and educated female labor force (% of population) in Korea (Republic) in 2003?
Offer a terse response. -28.5. What is the difference between the Unemployed and educated female labor force (% of population) of Estonia in 2002 and the Unemployed and educated female labor force (% of population) of Korea (Republic) in 2003?
Give a very brief answer. -6.9. What is the difference between the Unemployed and educated female labor force (% of population) in High income in 2002 and the Unemployed and educated female labor force (% of population) in Argentina in 2004?
Your answer should be very brief. 7.71. What is the difference between the Unemployed and educated female labor force (% of population) in High income in 2002 and the Unemployed and educated female labor force (% of population) in Estonia in 2004?
Your answer should be very brief. -8.09. What is the difference between the Unemployed and educated female labor force (% of population) of High income in 2002 and the Unemployed and educated female labor force (% of population) of Korea (Republic) in 2004?
Provide a succinct answer. -21.09. What is the difference between the Unemployed and educated female labor force (% of population) in Argentina in 2002 and the Unemployed and educated female labor force (% of population) in Estonia in 2004?
Ensure brevity in your answer.  -15.6. What is the difference between the Unemployed and educated female labor force (% of population) of Argentina in 2002 and the Unemployed and educated female labor force (% of population) of Korea (Republic) in 2004?
Your response must be concise. -28.6. What is the difference between the Unemployed and educated female labor force (% of population) in High income in 2003 and the Unemployed and educated female labor force (% of population) in Argentina in 2004?
Your answer should be very brief. 7.74. What is the difference between the Unemployed and educated female labor force (% of population) in High income in 2003 and the Unemployed and educated female labor force (% of population) in Estonia in 2004?
Your answer should be compact. -8.06. What is the difference between the Unemployed and educated female labor force (% of population) of High income in 2003 and the Unemployed and educated female labor force (% of population) of Korea (Republic) in 2004?
Make the answer very short. -21.06. What is the difference between the Unemployed and educated female labor force (% of population) of Argentina in 2003 and the Unemployed and educated female labor force (% of population) of Estonia in 2004?
Keep it short and to the point. -16.3. What is the difference between the Unemployed and educated female labor force (% of population) in Argentina in 2003 and the Unemployed and educated female labor force (% of population) in Korea (Republic) in 2004?
Offer a very short reply. -29.3. What is the average Unemployed and educated female labor force (% of population) in High income per year?
Keep it short and to the point. 44.92. What is the average Unemployed and educated female labor force (% of population) of Argentina per year?
Make the answer very short. 36.3. What is the average Unemployed and educated female labor force (% of population) in Estonia per year?
Offer a very short reply. 59.73. What is the average Unemployed and educated female labor force (% of population) in Korea (Republic) per year?
Your response must be concise. 65.58. In the year 1997, what is the difference between the Unemployed and educated female labor force (% of population) in High income and Unemployed and educated female labor force (% of population) in Argentina?
Provide a short and direct response. 7.55. In the year 1997, what is the difference between the Unemployed and educated female labor force (% of population) of High income and Unemployed and educated female labor force (% of population) of Estonia?
Provide a short and direct response. -8.05. In the year 1997, what is the difference between the Unemployed and educated female labor force (% of population) of High income and Unemployed and educated female labor force (% of population) of Korea (Republic)?
Your answer should be compact. -26.15. In the year 1997, what is the difference between the Unemployed and educated female labor force (% of population) of Argentina and Unemployed and educated female labor force (% of population) of Estonia?
Give a very brief answer. -15.6. In the year 1997, what is the difference between the Unemployed and educated female labor force (% of population) in Argentina and Unemployed and educated female labor force (% of population) in Korea (Republic)?
Give a very brief answer. -33.7. In the year 1997, what is the difference between the Unemployed and educated female labor force (% of population) of Estonia and Unemployed and educated female labor force (% of population) of Korea (Republic)?
Keep it short and to the point. -18.1. In the year 1998, what is the difference between the Unemployed and educated female labor force (% of population) of High income and Unemployed and educated female labor force (% of population) of Argentina?
Offer a very short reply. 10.34. In the year 1998, what is the difference between the Unemployed and educated female labor force (% of population) of High income and Unemployed and educated female labor force (% of population) of Estonia?
Your response must be concise. -16.06. In the year 1998, what is the difference between the Unemployed and educated female labor force (% of population) of High income and Unemployed and educated female labor force (% of population) of Korea (Republic)?
Offer a very short reply. -19.26. In the year 1998, what is the difference between the Unemployed and educated female labor force (% of population) of Argentina and Unemployed and educated female labor force (% of population) of Estonia?
Provide a short and direct response. -26.4. In the year 1998, what is the difference between the Unemployed and educated female labor force (% of population) of Argentina and Unemployed and educated female labor force (% of population) of Korea (Republic)?
Offer a terse response. -29.6. In the year 1998, what is the difference between the Unemployed and educated female labor force (% of population) in Estonia and Unemployed and educated female labor force (% of population) in Korea (Republic)?
Your answer should be very brief. -3.2. In the year 1999, what is the difference between the Unemployed and educated female labor force (% of population) of High income and Unemployed and educated female labor force (% of population) of Argentina?
Your answer should be compact. 7.7. In the year 1999, what is the difference between the Unemployed and educated female labor force (% of population) in High income and Unemployed and educated female labor force (% of population) in Estonia?
Make the answer very short. -14.8. In the year 1999, what is the difference between the Unemployed and educated female labor force (% of population) in High income and Unemployed and educated female labor force (% of population) in Korea (Republic)?
Offer a terse response. -20.4. In the year 1999, what is the difference between the Unemployed and educated female labor force (% of population) of Argentina and Unemployed and educated female labor force (% of population) of Estonia?
Provide a short and direct response. -22.5. In the year 1999, what is the difference between the Unemployed and educated female labor force (% of population) of Argentina and Unemployed and educated female labor force (% of population) of Korea (Republic)?
Give a very brief answer. -28.1. In the year 2000, what is the difference between the Unemployed and educated female labor force (% of population) in High income and Unemployed and educated female labor force (% of population) in Argentina?
Your answer should be compact. 10.17. In the year 2000, what is the difference between the Unemployed and educated female labor force (% of population) in High income and Unemployed and educated female labor force (% of population) in Estonia?
Keep it short and to the point. -21.43. In the year 2000, what is the difference between the Unemployed and educated female labor force (% of population) in High income and Unemployed and educated female labor force (% of population) in Korea (Republic)?
Keep it short and to the point. -17.83. In the year 2000, what is the difference between the Unemployed and educated female labor force (% of population) in Argentina and Unemployed and educated female labor force (% of population) in Estonia?
Keep it short and to the point. -31.6. In the year 2000, what is the difference between the Unemployed and educated female labor force (% of population) in Argentina and Unemployed and educated female labor force (% of population) in Korea (Republic)?
Your answer should be compact. -28. In the year 2001, what is the difference between the Unemployed and educated female labor force (% of population) of High income and Unemployed and educated female labor force (% of population) of Argentina?
Give a very brief answer. 9.12. In the year 2001, what is the difference between the Unemployed and educated female labor force (% of population) in High income and Unemployed and educated female labor force (% of population) in Estonia?
Make the answer very short. -20.88. In the year 2001, what is the difference between the Unemployed and educated female labor force (% of population) of High income and Unemployed and educated female labor force (% of population) of Korea (Republic)?
Keep it short and to the point. -20.48. In the year 2001, what is the difference between the Unemployed and educated female labor force (% of population) of Argentina and Unemployed and educated female labor force (% of population) of Korea (Republic)?
Your answer should be compact. -29.6. In the year 2002, what is the difference between the Unemployed and educated female labor force (% of population) of High income and Unemployed and educated female labor force (% of population) of Argentina?
Provide a short and direct response. 7.51. In the year 2002, what is the difference between the Unemployed and educated female labor force (% of population) of High income and Unemployed and educated female labor force (% of population) of Estonia?
Provide a short and direct response. -14.09. In the year 2002, what is the difference between the Unemployed and educated female labor force (% of population) in High income and Unemployed and educated female labor force (% of population) in Korea (Republic)?
Provide a succinct answer. -19.69. In the year 2002, what is the difference between the Unemployed and educated female labor force (% of population) of Argentina and Unemployed and educated female labor force (% of population) of Estonia?
Give a very brief answer. -21.6. In the year 2002, what is the difference between the Unemployed and educated female labor force (% of population) in Argentina and Unemployed and educated female labor force (% of population) in Korea (Republic)?
Your response must be concise. -27.2. In the year 2002, what is the difference between the Unemployed and educated female labor force (% of population) in Estonia and Unemployed and educated female labor force (% of population) in Korea (Republic)?
Provide a short and direct response. -5.6. In the year 2003, what is the difference between the Unemployed and educated female labor force (% of population) in High income and Unemployed and educated female labor force (% of population) in Argentina?
Give a very brief answer. 8.24. In the year 2003, what is the difference between the Unemployed and educated female labor force (% of population) in High income and Unemployed and educated female labor force (% of population) in Estonia?
Your answer should be compact. -15.66. In the year 2003, what is the difference between the Unemployed and educated female labor force (% of population) in High income and Unemployed and educated female labor force (% of population) in Korea (Republic)?
Ensure brevity in your answer.  -20.96. In the year 2003, what is the difference between the Unemployed and educated female labor force (% of population) in Argentina and Unemployed and educated female labor force (% of population) in Estonia?
Give a very brief answer. -23.9. In the year 2003, what is the difference between the Unemployed and educated female labor force (% of population) of Argentina and Unemployed and educated female labor force (% of population) of Korea (Republic)?
Offer a terse response. -29.2. In the year 2004, what is the difference between the Unemployed and educated female labor force (% of population) in High income and Unemployed and educated female labor force (% of population) in Argentina?
Your answer should be compact. 8.32. In the year 2004, what is the difference between the Unemployed and educated female labor force (% of population) in High income and Unemployed and educated female labor force (% of population) in Estonia?
Give a very brief answer. -7.48. In the year 2004, what is the difference between the Unemployed and educated female labor force (% of population) of High income and Unemployed and educated female labor force (% of population) of Korea (Republic)?
Your response must be concise. -20.48. In the year 2004, what is the difference between the Unemployed and educated female labor force (% of population) of Argentina and Unemployed and educated female labor force (% of population) of Estonia?
Keep it short and to the point. -15.8. In the year 2004, what is the difference between the Unemployed and educated female labor force (% of population) in Argentina and Unemployed and educated female labor force (% of population) in Korea (Republic)?
Your answer should be very brief. -28.8. In the year 2004, what is the difference between the Unemployed and educated female labor force (% of population) in Estonia and Unemployed and educated female labor force (% of population) in Korea (Republic)?
Keep it short and to the point. -13. What is the ratio of the Unemployed and educated female labor force (% of population) of High income in 1997 to that in 1998?
Provide a short and direct response. 0.96. What is the ratio of the Unemployed and educated female labor force (% of population) in Argentina in 1997 to that in 1998?
Offer a terse response. 1.04. What is the ratio of the Unemployed and educated female labor force (% of population) of Estonia in 1997 to that in 1998?
Provide a succinct answer. 0.84. What is the ratio of the Unemployed and educated female labor force (% of population) of Korea (Republic) in 1997 to that in 1998?
Offer a terse response. 1.08. What is the ratio of the Unemployed and educated female labor force (% of population) of High income in 1997 to that in 1999?
Offer a terse response. 0.96. What is the ratio of the Unemployed and educated female labor force (% of population) of Argentina in 1997 to that in 1999?
Offer a very short reply. 0.96. What is the ratio of the Unemployed and educated female labor force (% of population) in Estonia in 1997 to that in 1999?
Offer a terse response. 0.86. What is the ratio of the Unemployed and educated female labor force (% of population) in Korea (Republic) in 1997 to that in 1999?
Offer a terse response. 1.06. What is the ratio of the Unemployed and educated female labor force (% of population) in High income in 1997 to that in 2000?
Offer a very short reply. 0.92. What is the ratio of the Unemployed and educated female labor force (% of population) in Argentina in 1997 to that in 2000?
Provide a short and direct response. 0.97. What is the ratio of the Unemployed and educated female labor force (% of population) in Estonia in 1997 to that in 2000?
Provide a short and direct response. 0.74. What is the ratio of the Unemployed and educated female labor force (% of population) in Korea (Republic) in 1997 to that in 2000?
Offer a terse response. 1.07. What is the ratio of the Unemployed and educated female labor force (% of population) of High income in 1997 to that in 2001?
Your response must be concise. 0.9. What is the ratio of the Unemployed and educated female labor force (% of population) in Argentina in 1997 to that in 2001?
Make the answer very short. 0.92. What is the ratio of the Unemployed and educated female labor force (% of population) of Estonia in 1997 to that in 2001?
Your answer should be compact. 0.74. What is the ratio of the Unemployed and educated female labor force (% of population) of Korea (Republic) in 1997 to that in 2001?
Your response must be concise. 1.02. What is the ratio of the Unemployed and educated female labor force (% of population) in High income in 1997 to that in 2002?
Your answer should be very brief. 0.92. What is the ratio of the Unemployed and educated female labor force (% of population) in Argentina in 1997 to that in 2002?
Provide a succinct answer. 0.9. What is the ratio of the Unemployed and educated female labor force (% of population) in Estonia in 1997 to that in 2002?
Your answer should be compact. 0.83. What is the ratio of the Unemployed and educated female labor force (% of population) in Korea (Republic) in 1997 to that in 2002?
Ensure brevity in your answer.  1.04. What is the ratio of the Unemployed and educated female labor force (% of population) of High income in 1997 to that in 2003?
Offer a terse response. 0.92. What is the ratio of the Unemployed and educated female labor force (% of population) of Argentina in 1997 to that in 2003?
Make the answer very short. 0.91. What is the ratio of the Unemployed and educated female labor force (% of population) of Estonia in 1997 to that in 2003?
Your response must be concise. 0.81. What is the ratio of the Unemployed and educated female labor force (% of population) in Korea (Republic) in 1997 to that in 2003?
Provide a short and direct response. 1.02. What is the ratio of the Unemployed and educated female labor force (% of population) in High income in 1997 to that in 2004?
Your response must be concise. 0.9. What is the ratio of the Unemployed and educated female labor force (% of population) in Argentina in 1997 to that in 2004?
Offer a very short reply. 0.9. What is the ratio of the Unemployed and educated female labor force (% of population) of Estonia in 1997 to that in 2004?
Your answer should be very brief. 0.93. What is the ratio of the Unemployed and educated female labor force (% of population) in Korea (Republic) in 1997 to that in 2004?
Ensure brevity in your answer.  1.02. What is the ratio of the Unemployed and educated female labor force (% of population) of Argentina in 1998 to that in 1999?
Make the answer very short. 0.92. What is the ratio of the Unemployed and educated female labor force (% of population) of Estonia in 1998 to that in 1999?
Your answer should be compact. 1.02. What is the ratio of the Unemployed and educated female labor force (% of population) in Korea (Republic) in 1998 to that in 1999?
Offer a terse response. 0.98. What is the ratio of the Unemployed and educated female labor force (% of population) in High income in 1998 to that in 2000?
Offer a terse response. 0.95. What is the ratio of the Unemployed and educated female labor force (% of population) in Argentina in 1998 to that in 2000?
Keep it short and to the point. 0.93. What is the ratio of the Unemployed and educated female labor force (% of population) in Estonia in 1998 to that in 2000?
Offer a terse response. 0.89. What is the ratio of the Unemployed and educated female labor force (% of population) in Korea (Republic) in 1998 to that in 2000?
Make the answer very short. 0.99. What is the ratio of the Unemployed and educated female labor force (% of population) in High income in 1998 to that in 2001?
Keep it short and to the point. 0.94. What is the ratio of the Unemployed and educated female labor force (% of population) in Argentina in 1998 to that in 2001?
Offer a terse response. 0.89. What is the ratio of the Unemployed and educated female labor force (% of population) of Estonia in 1998 to that in 2001?
Make the answer very short. 0.89. What is the ratio of the Unemployed and educated female labor force (% of population) of Korea (Republic) in 1998 to that in 2001?
Give a very brief answer. 0.94. What is the ratio of the Unemployed and educated female labor force (% of population) in High income in 1998 to that in 2002?
Make the answer very short. 0.95. What is the ratio of the Unemployed and educated female labor force (% of population) of Argentina in 1998 to that in 2002?
Offer a terse response. 0.87. What is the ratio of the Unemployed and educated female labor force (% of population) of Estonia in 1998 to that in 2002?
Keep it short and to the point. 0.99. What is the ratio of the Unemployed and educated female labor force (% of population) in Korea (Republic) in 1998 to that in 2002?
Give a very brief answer. 0.96. What is the ratio of the Unemployed and educated female labor force (% of population) in High income in 1998 to that in 2003?
Offer a very short reply. 0.95. What is the ratio of the Unemployed and educated female labor force (% of population) in Argentina in 1998 to that in 2003?
Give a very brief answer. 0.88. What is the ratio of the Unemployed and educated female labor force (% of population) in Estonia in 1998 to that in 2003?
Make the answer very short. 0.97. What is the ratio of the Unemployed and educated female labor force (% of population) of Korea (Republic) in 1998 to that in 2003?
Offer a very short reply. 0.94. What is the ratio of the Unemployed and educated female labor force (% of population) of High income in 1998 to that in 2004?
Ensure brevity in your answer.  0.94. What is the ratio of the Unemployed and educated female labor force (% of population) of Argentina in 1998 to that in 2004?
Offer a very short reply. 0.87. What is the ratio of the Unemployed and educated female labor force (% of population) of Estonia in 1998 to that in 2004?
Offer a terse response. 1.11. What is the ratio of the Unemployed and educated female labor force (% of population) in Korea (Republic) in 1998 to that in 2004?
Ensure brevity in your answer.  0.94. What is the ratio of the Unemployed and educated female labor force (% of population) in High income in 1999 to that in 2000?
Keep it short and to the point. 0.95. What is the ratio of the Unemployed and educated female labor force (% of population) of Argentina in 1999 to that in 2000?
Offer a very short reply. 1.01. What is the ratio of the Unemployed and educated female labor force (% of population) of Estonia in 1999 to that in 2000?
Provide a succinct answer. 0.87. What is the ratio of the Unemployed and educated female labor force (% of population) in Korea (Republic) in 1999 to that in 2000?
Your answer should be compact. 1.01. What is the ratio of the Unemployed and educated female labor force (% of population) in High income in 1999 to that in 2001?
Your answer should be compact. 0.94. What is the ratio of the Unemployed and educated female labor force (% of population) in Argentina in 1999 to that in 2001?
Offer a terse response. 0.96. What is the ratio of the Unemployed and educated female labor force (% of population) in Estonia in 1999 to that in 2001?
Give a very brief answer. 0.87. What is the ratio of the Unemployed and educated female labor force (% of population) in Korea (Republic) in 1999 to that in 2001?
Provide a short and direct response. 0.96. What is the ratio of the Unemployed and educated female labor force (% of population) of High income in 1999 to that in 2002?
Offer a terse response. 0.95. What is the ratio of the Unemployed and educated female labor force (% of population) of Argentina in 1999 to that in 2002?
Keep it short and to the point. 0.94. What is the ratio of the Unemployed and educated female labor force (% of population) of Estonia in 1999 to that in 2002?
Provide a succinct answer. 0.97. What is the ratio of the Unemployed and educated female labor force (% of population) in Korea (Republic) in 1999 to that in 2002?
Provide a succinct answer. 0.98. What is the ratio of the Unemployed and educated female labor force (% of population) in High income in 1999 to that in 2003?
Your answer should be very brief. 0.95. What is the ratio of the Unemployed and educated female labor force (% of population) of Argentina in 1999 to that in 2003?
Your answer should be very brief. 0.95. What is the ratio of the Unemployed and educated female labor force (% of population) of Estonia in 1999 to that in 2003?
Offer a very short reply. 0.95. What is the ratio of the Unemployed and educated female labor force (% of population) in Korea (Republic) in 1999 to that in 2003?
Offer a very short reply. 0.96. What is the ratio of the Unemployed and educated female labor force (% of population) of High income in 1999 to that in 2004?
Keep it short and to the point. 0.94. What is the ratio of the Unemployed and educated female labor force (% of population) in Argentina in 1999 to that in 2004?
Your answer should be very brief. 0.94. What is the ratio of the Unemployed and educated female labor force (% of population) in Estonia in 1999 to that in 2004?
Make the answer very short. 1.08. What is the ratio of the Unemployed and educated female labor force (% of population) of Korea (Republic) in 1999 to that in 2004?
Provide a succinct answer. 0.96. What is the ratio of the Unemployed and educated female labor force (% of population) of High income in 2000 to that in 2001?
Give a very brief answer. 0.99. What is the ratio of the Unemployed and educated female labor force (% of population) in Argentina in 2000 to that in 2001?
Offer a terse response. 0.95. What is the ratio of the Unemployed and educated female labor force (% of population) in Estonia in 2000 to that in 2001?
Make the answer very short. 1. What is the ratio of the Unemployed and educated female labor force (% of population) in Korea (Republic) in 2000 to that in 2001?
Provide a succinct answer. 0.95. What is the ratio of the Unemployed and educated female labor force (% of population) of High income in 2000 to that in 2002?
Your answer should be compact. 1. What is the ratio of the Unemployed and educated female labor force (% of population) of Argentina in 2000 to that in 2002?
Keep it short and to the point. 0.93. What is the ratio of the Unemployed and educated female labor force (% of population) of Estonia in 2000 to that in 2002?
Offer a very short reply. 1.12. What is the ratio of the Unemployed and educated female labor force (% of population) of Argentina in 2000 to that in 2003?
Give a very brief answer. 0.95. What is the ratio of the Unemployed and educated female labor force (% of population) of Estonia in 2000 to that in 2003?
Offer a very short reply. 1.09. What is the ratio of the Unemployed and educated female labor force (% of population) in Korea (Republic) in 2000 to that in 2003?
Your response must be concise. 0.95. What is the ratio of the Unemployed and educated female labor force (% of population) of High income in 2000 to that in 2004?
Give a very brief answer. 0.99. What is the ratio of the Unemployed and educated female labor force (% of population) in Argentina in 2000 to that in 2004?
Make the answer very short. 0.93. What is the ratio of the Unemployed and educated female labor force (% of population) in Estonia in 2000 to that in 2004?
Keep it short and to the point. 1.25. What is the ratio of the Unemployed and educated female labor force (% of population) of Korea (Republic) in 2000 to that in 2004?
Give a very brief answer. 0.95. What is the ratio of the Unemployed and educated female labor force (% of population) in High income in 2001 to that in 2002?
Make the answer very short. 1.01. What is the ratio of the Unemployed and educated female labor force (% of population) of Argentina in 2001 to that in 2002?
Offer a terse response. 0.97. What is the ratio of the Unemployed and educated female labor force (% of population) of Estonia in 2001 to that in 2002?
Ensure brevity in your answer.  1.12. What is the ratio of the Unemployed and educated female labor force (% of population) of Korea (Republic) in 2001 to that in 2002?
Ensure brevity in your answer.  1.02. What is the ratio of the Unemployed and educated female labor force (% of population) of High income in 2001 to that in 2003?
Your response must be concise. 1.01. What is the ratio of the Unemployed and educated female labor force (% of population) in Estonia in 2001 to that in 2003?
Provide a short and direct response. 1.09. What is the ratio of the Unemployed and educated female labor force (% of population) of High income in 2001 to that in 2004?
Keep it short and to the point. 1. What is the ratio of the Unemployed and educated female labor force (% of population) in Argentina in 2001 to that in 2004?
Give a very brief answer. 0.98. What is the ratio of the Unemployed and educated female labor force (% of population) in Estonia in 2001 to that in 2004?
Give a very brief answer. 1.25. What is the ratio of the Unemployed and educated female labor force (% of population) of Korea (Republic) in 2001 to that in 2004?
Your response must be concise. 1. What is the ratio of the Unemployed and educated female labor force (% of population) in Argentina in 2002 to that in 2003?
Your response must be concise. 1.02. What is the ratio of the Unemployed and educated female labor force (% of population) of Korea (Republic) in 2002 to that in 2003?
Keep it short and to the point. 0.98. What is the ratio of the Unemployed and educated female labor force (% of population) of High income in 2002 to that in 2004?
Ensure brevity in your answer.  0.99. What is the ratio of the Unemployed and educated female labor force (% of population) of Estonia in 2002 to that in 2004?
Provide a short and direct response. 1.11. What is the ratio of the Unemployed and educated female labor force (% of population) of Korea (Republic) in 2002 to that in 2004?
Your answer should be compact. 0.98. What is the ratio of the Unemployed and educated female labor force (% of population) of High income in 2003 to that in 2004?
Give a very brief answer. 0.99. What is the ratio of the Unemployed and educated female labor force (% of population) of Argentina in 2003 to that in 2004?
Offer a very short reply. 0.99. What is the ratio of the Unemployed and educated female labor force (% of population) of Estonia in 2003 to that in 2004?
Provide a succinct answer. 1.14. What is the ratio of the Unemployed and educated female labor force (% of population) of Korea (Republic) in 2003 to that in 2004?
Keep it short and to the point. 1. What is the difference between the highest and the second highest Unemployed and educated female labor force (% of population) in High income?
Keep it short and to the point. 0.01. What is the difference between the highest and the second highest Unemployed and educated female labor force (% of population) of Estonia?
Your response must be concise. 0.1. What is the difference between the highest and the lowest Unemployed and educated female labor force (% of population) in High income?
Keep it short and to the point. 4.48. What is the difference between the highest and the lowest Unemployed and educated female labor force (% of population) in Argentina?
Make the answer very short. 5.1. What is the difference between the highest and the lowest Unemployed and educated female labor force (% of population) of Korea (Republic)?
Keep it short and to the point. 5.3. 